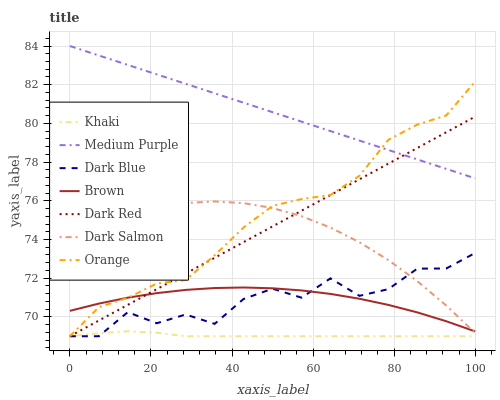Does Khaki have the minimum area under the curve?
Answer yes or no. Yes. Does Medium Purple have the maximum area under the curve?
Answer yes or no. Yes. Does Dark Red have the minimum area under the curve?
Answer yes or no. No. Does Dark Red have the maximum area under the curve?
Answer yes or no. No. Is Dark Red the smoothest?
Answer yes or no. Yes. Is Dark Blue the roughest?
Answer yes or no. Yes. Is Khaki the smoothest?
Answer yes or no. No. Is Khaki the roughest?
Answer yes or no. No. Does Khaki have the lowest value?
Answer yes or no. Yes. Does Dark Salmon have the lowest value?
Answer yes or no. No. Does Medium Purple have the highest value?
Answer yes or no. Yes. Does Dark Red have the highest value?
Answer yes or no. No. Is Brown less than Medium Purple?
Answer yes or no. Yes. Is Brown greater than Khaki?
Answer yes or no. Yes. Does Dark Red intersect Medium Purple?
Answer yes or no. Yes. Is Dark Red less than Medium Purple?
Answer yes or no. No. Is Dark Red greater than Medium Purple?
Answer yes or no. No. Does Brown intersect Medium Purple?
Answer yes or no. No. 